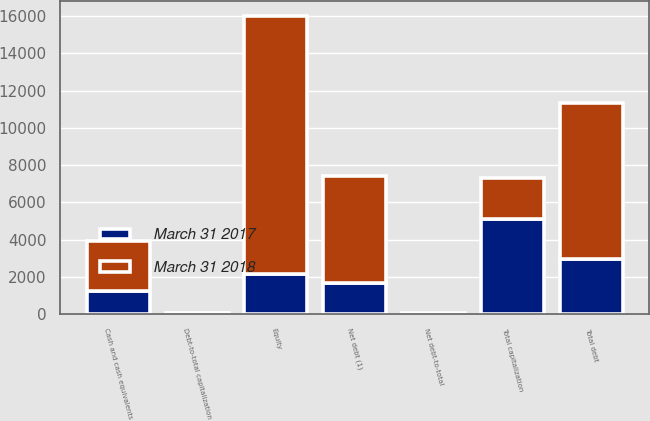Convert chart. <chart><loc_0><loc_0><loc_500><loc_500><stacked_bar_chart><ecel><fcel>Total debt<fcel>Cash and cash equivalents<fcel>Net debt (1)<fcel>Equity<fcel>Total capitalization<fcel>Debt-to-total capitalization<fcel>Net debt-to-total<nl><fcel>March 31 2018<fcel>8379<fcel>2648<fcel>5731<fcel>13837<fcel>2166<fcel>37.7<fcel>25.8<nl><fcel>March 31 2017<fcel>2963<fcel>1263<fcel>1700<fcel>2166<fcel>5129<fcel>57.8<fcel>33.1<nl></chart> 